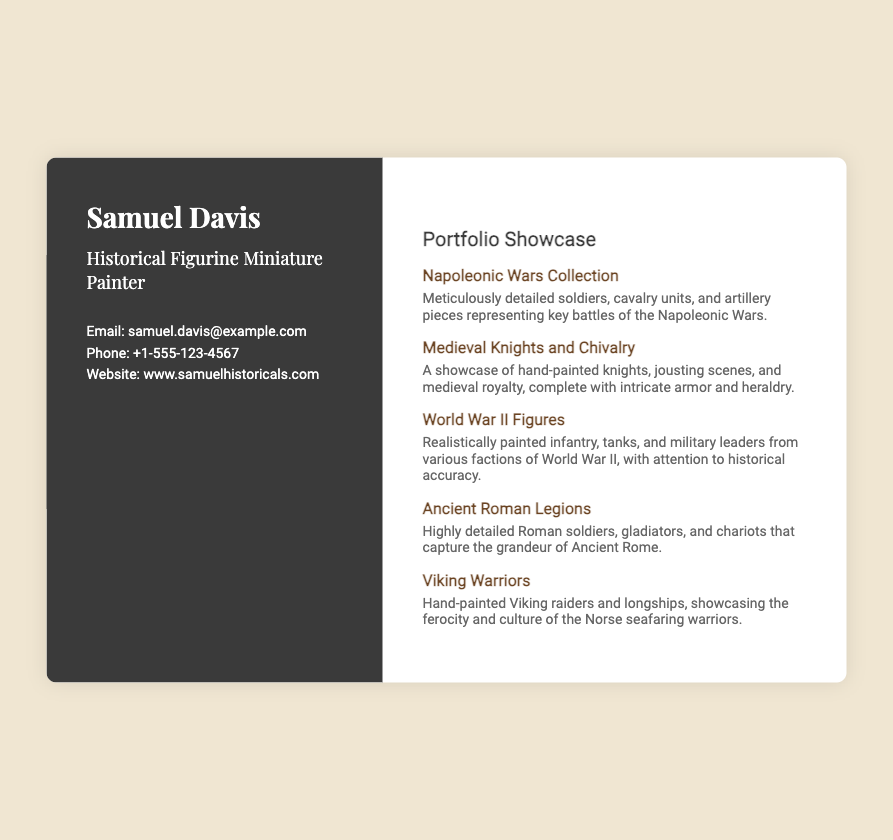What is the name of the miniature painter? The name of the painter is displayed prominently at the top left of the card.
Answer: Samuel Davis What is the profession listed on the business card? The profession is mentioned below the name, indicating what Samuel Davis does.
Answer: Historical Figurine Miniature Painter What is the email address provided? The email address is part of the contact information section.
Answer: samuel.davis@example.com How many portfolio items are showcased? The count of items can be determined from the portfolio section of the card.
Answer: Five Which collection features detailed soldiers from the Napoleonic Wars? The specific collection is listed in the portfolio showcase.
Answer: Napoleonic Wars Collection What is the phone number listed on the card? The phone number is part of the contact information section.
Answer: +1-555-123-4567 What social media platform is mentioned for Samuel Davis? The social media section includes links to multiple platforms; one is highlighted prominently.
Answer: Instagram What is the website for Samuel Davis's portfolio? The website is provided in the contact section for anyone interested in his work.
Answer: www.samuelhistoricals.com Which historical theme features highly detailed figures of Roman soldiers? The theme can be inferred from the portfolio items listed on the card.
Answer: Ancient Roman Legions 